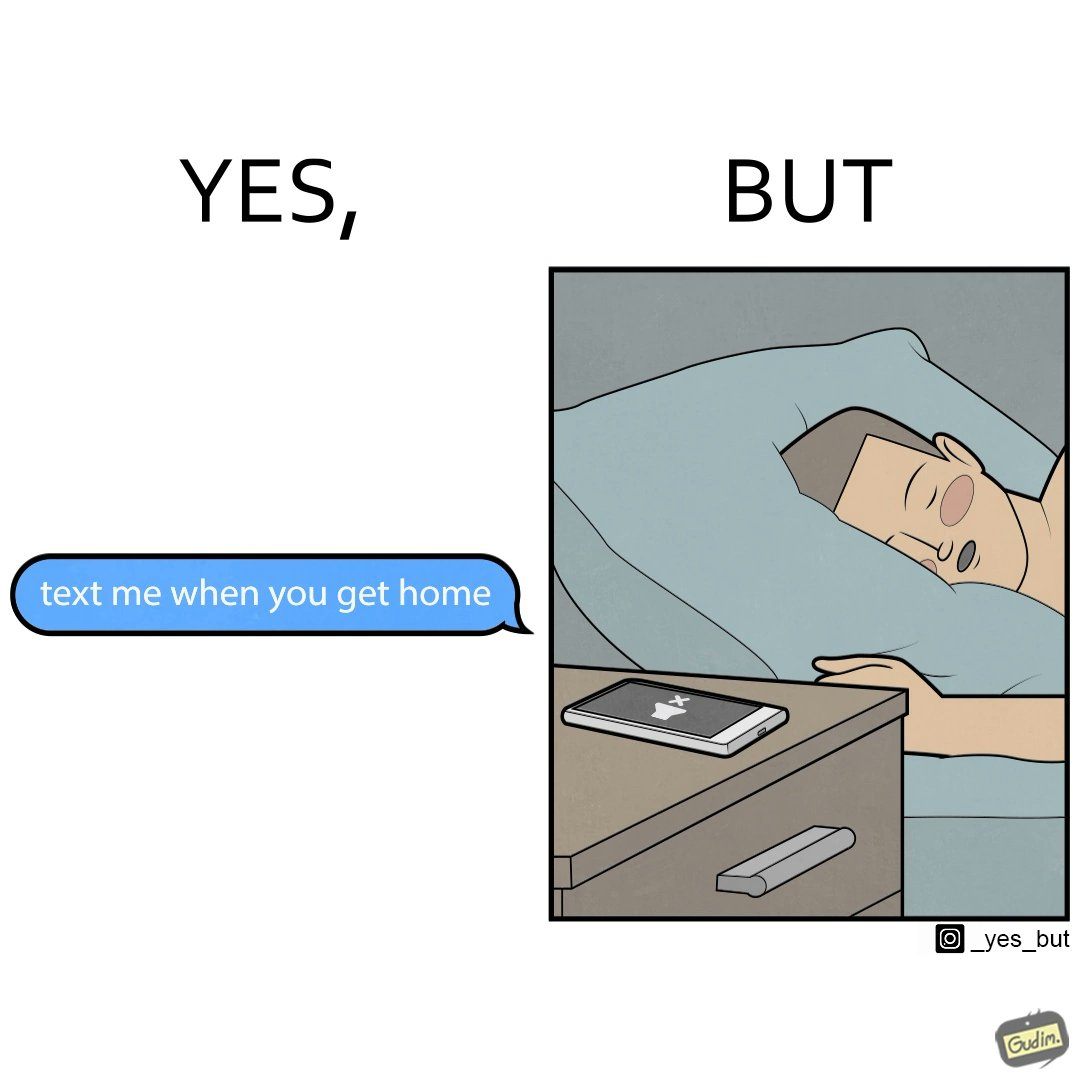What is shown in this image? The images are funny since they show how a sender wants the recipient to revert once he gets back home but the tired recipient ends up falling asleep completely forgetting about the message while the sender keeps waiting for a reply. The fact that the recipient leaves his phone on silent mode makes it even funnier since the probability of the sender being able to contact him becomes even slimmer. 